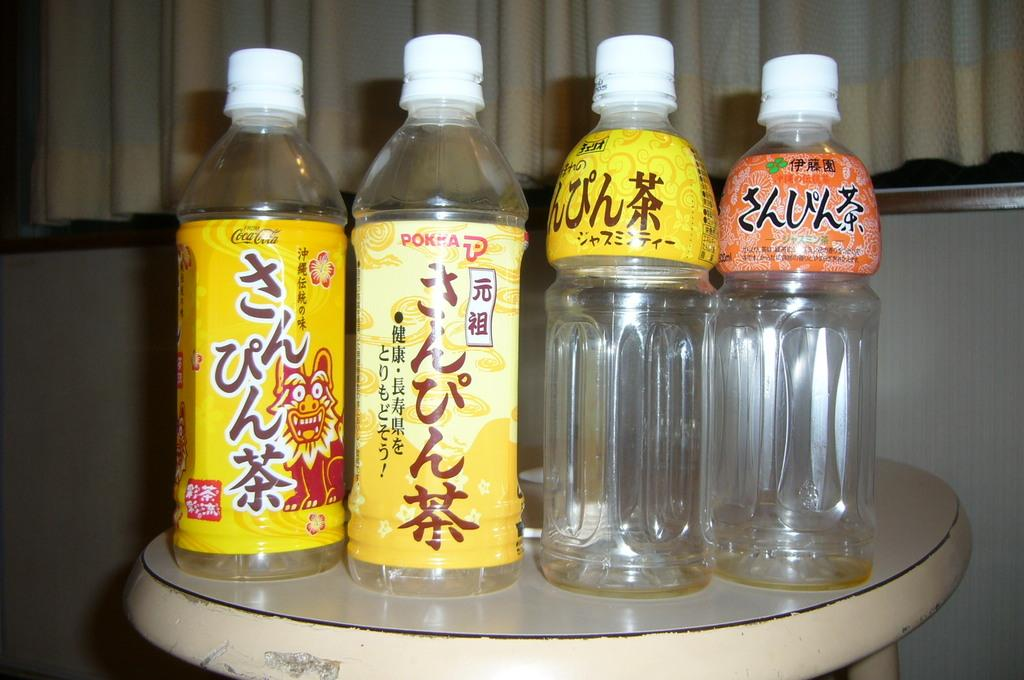<image>
Share a concise interpretation of the image provided. four bottles of liquid with chinese writing symbols with the first bottle saying cocacola 